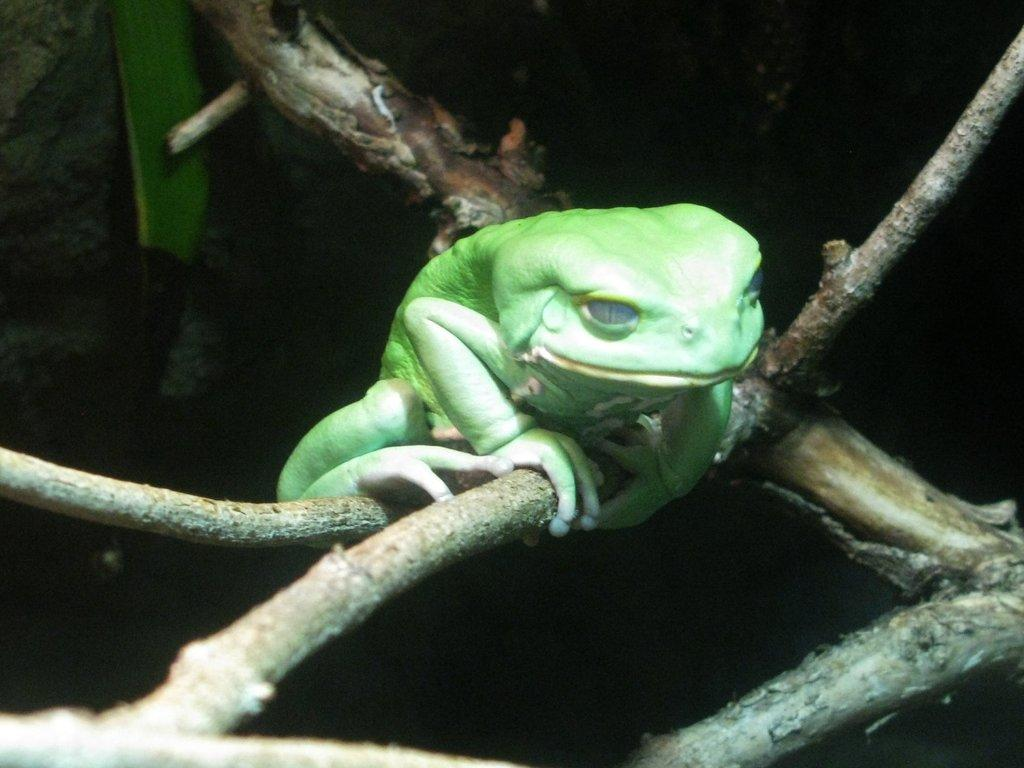What is the main subject of the picture? The main subject of the picture is a frog. Where is the frog located in the image? The frog is on a branch of a tree. What is the color of the frog? The frog is green in color. What type of cloth is draped over the sofa in the image? There is no sofa or cloth present in the image; it features a frog on a tree branch. 